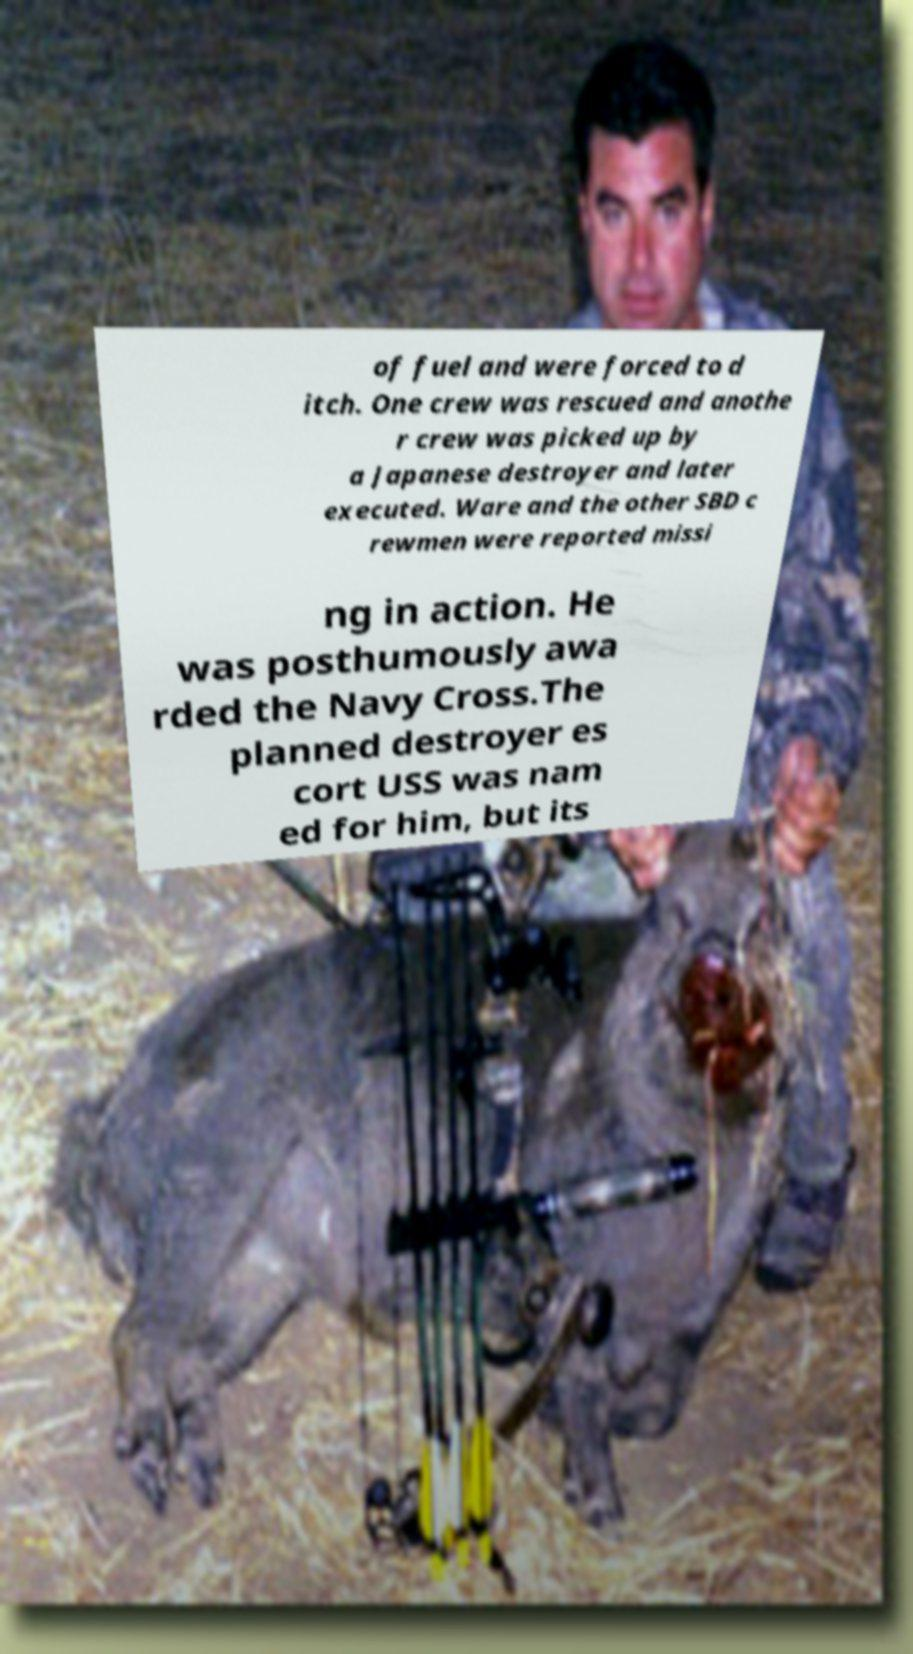Could you assist in decoding the text presented in this image and type it out clearly? of fuel and were forced to d itch. One crew was rescued and anothe r crew was picked up by a Japanese destroyer and later executed. Ware and the other SBD c rewmen were reported missi ng in action. He was posthumously awa rded the Navy Cross.The planned destroyer es cort USS was nam ed for him, but its 